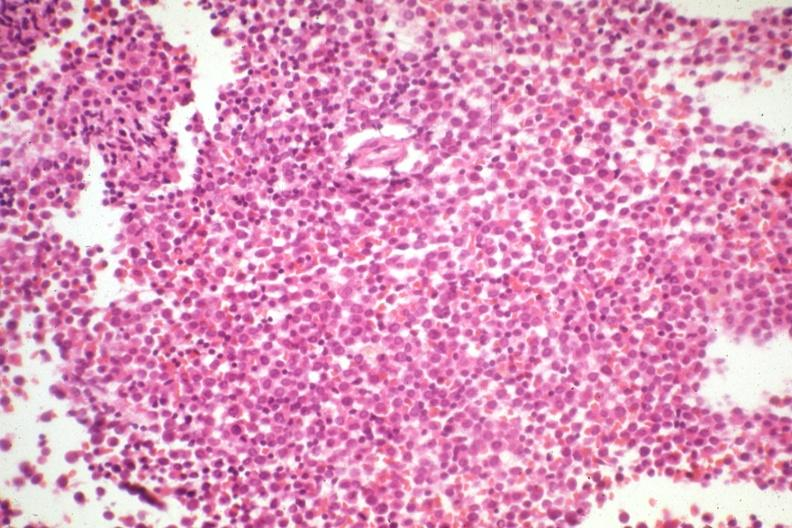s this therapy had not knocked out leukemia cells?
Answer the question using a single word or phrase. Yes 